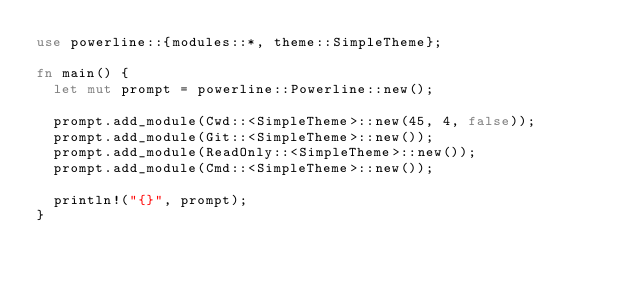Convert code to text. <code><loc_0><loc_0><loc_500><loc_500><_Rust_>use powerline::{modules::*, theme::SimpleTheme};

fn main() {
	let mut prompt = powerline::Powerline::new();

	prompt.add_module(Cwd::<SimpleTheme>::new(45, 4, false));
	prompt.add_module(Git::<SimpleTheme>::new());
	prompt.add_module(ReadOnly::<SimpleTheme>::new());
	prompt.add_module(Cmd::<SimpleTheme>::new());

	println!("{}", prompt);
}
</code> 